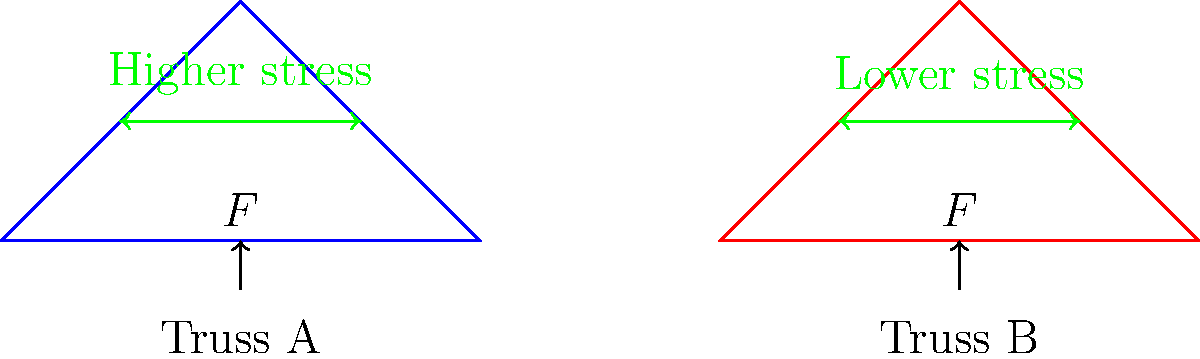In the context of bridge design, consider two truss configurations: Truss A (equilateral triangle) and Truss B (isosceles triangle with a higher apex). Both trusses are subjected to identical vertical loads ($F$) at their bases. Which truss design is likely to experience lower overall stress distribution, and why? To analyze the stress distribution in these truss designs, we need to consider several factors:

1. Force distribution: In both trusses, the vertical load $F$ is distributed between the two inclined members.

2. Member length: Truss B has longer inclined members compared to Truss A.

3. Angle of inclination: Truss B has a steeper angle between the inclined members and the horizontal base.

4. Stress calculation: Stress ($\sigma$) is given by $\sigma = \frac{F}{A}$, where $F$ is the force and $A$ is the cross-sectional area.

5. Force resolution: The force in each member can be resolved into vertical and horizontal components.

6. Truss A (equilateral):
   - Forces are equally distributed among all members.
   - Angle between members is 60°.
   - Force in each inclined member: $F_m = \frac{F}{2\sin 60°} = \frac{F}{\sqrt{3}}$

7. Truss B (isosceles):
   - Forces are not equally distributed.
   - Angle between inclined member and base is greater than 60°.
   - Force in each inclined member: $F_m = \frac{F}{2\sin \theta}$, where $\theta > 60°$

8. Comparison:
   - As $\sin \theta$ increases, $F_m$ decreases.
   - Truss B will have a smaller force in each inclined member.
   - Assuming equal cross-sectional areas, Truss B will experience lower stress.

9. Additional considerations:
   - Truss B has longer members, which could affect buckling resistance.
   - The steeper angle in Truss B provides better vertical load resistance.
Answer: Truss B (isosceles) experiences lower overall stress distribution due to its steeper angle, resulting in smaller forces in the inclined members. 